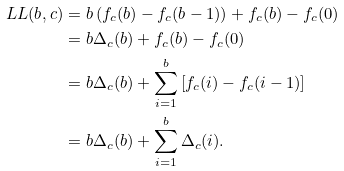Convert formula to latex. <formula><loc_0><loc_0><loc_500><loc_500>L L ( b , c ) & = b \left ( f _ { c } ( b ) - f _ { c } ( b - 1 ) \right ) + f _ { c } ( b ) - f _ { c } ( 0 ) \\ & = b \Delta _ { c } ( b ) + f _ { c } ( b ) - f _ { c } ( 0 ) \\ & = b \Delta _ { c } ( b ) + \sum _ { i = 1 } ^ { b } \left [ f _ { c } ( i ) - f _ { c } ( i - 1 ) \right ] \\ & = b \Delta _ { c } ( b ) + \sum _ { i = 1 } ^ { b } \Delta _ { c } ( i ) .</formula> 